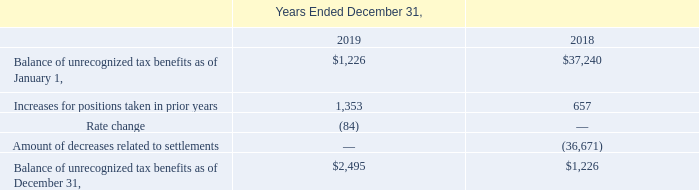The following is a tabular reconciliation of the total amounts of unrecognized tax benefits (excluding interest and penalties):
Included in the balance of unrecognized tax benefits as of December 31, 2019 and 2018 are $2,495 and $220, respectively, of tax benefits that, if recognized would affect the effective tax rate.
The Company records interest and penalties on unrecognized tax benefits in its provision for income taxes. Accrued interest and penalties are included within the related liability for unrecognized tax benefit line on the consolidated balance sheets. During the years ended December 31, 2019 and 2018, the Company accrued interest of $114 and $0, respectively, and recorded liabilities for interest and penalties of $252 and $0, respectively.
After taking into consideration tax attributes, such as net operating loss carryforwards and interest, the Company’s unrecognized tax benefits represent a noncurrent reserve for uncertain tax positions of $864 and $220 as of December 31, 2019 and 2018, respectively.
The U.S. Internal Revenue Service completed exams on the Company's U.S. federal income tax returns for years 2012 - 2015. With few exceptions, the Company is no longer subject to state and local income tax examinations by tax authorities for years before 2015. The Company conducts business and files income tax returns in numerous states. Currently, one of the Company's state tax returns is under examination by a state as part of routine audits conducted in the ordinary course of business.
The future utilization of state net operating losses could potentially subject the Company to state examinations prior to the otherwise applicable statute of limitation. States vary in carryforward periods but generally extend up to 20 years or a period consistent with the federal limits under the Tax Cuts and Jobs Act.
For which years did U.S. Internal Revenue Service completed exams on the Company's U.S. federal income tax returns? 2012 - 2015. What is the change in Balance of unrecognized tax benefits as of January 1, from Years Ended December 31, 2018 to 2019? 1,226-37,240
Answer: -36014. What is the average Balance of unrecognized tax benefits as of January 1, for Years Ended December 31, 2018 to 2019? (1,226+37,240) / 2
Answer: 19233. In which year was Increases for positions taken in prior years less than 1,000? Locate and analyze increases for positions taken in prior years in row 4
answer: 2018. What was the Rate change in 2019 and 2018 respectively? (84), 0. What was the Balance of unrecognized tax benefits as of December 31, 2019? $2,495. 